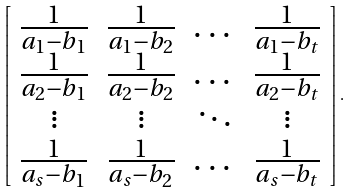Convert formula to latex. <formula><loc_0><loc_0><loc_500><loc_500>\left [ \begin{array} { c c c c } \frac { 1 } { a _ { 1 } - b _ { 1 } } & \frac { 1 } { a _ { 1 } - b _ { 2 } } & \dots & \frac { 1 } { a _ { 1 } - b _ { t } } \\ \frac { 1 } { a _ { 2 } - b _ { 1 } } & \frac { 1 } { a _ { 2 } - b _ { 2 } } & \dots & \frac { 1 } { a _ { 2 } - b _ { t } } \\ \vdots & \vdots & \ddots & \vdots \\ \frac { 1 } { a _ { s } - b _ { 1 } } & \frac { 1 } { a _ { s } - b _ { 2 } } & \dots & \frac { 1 } { a _ { s } - b _ { t } } \\ \end{array} \right ] .</formula> 